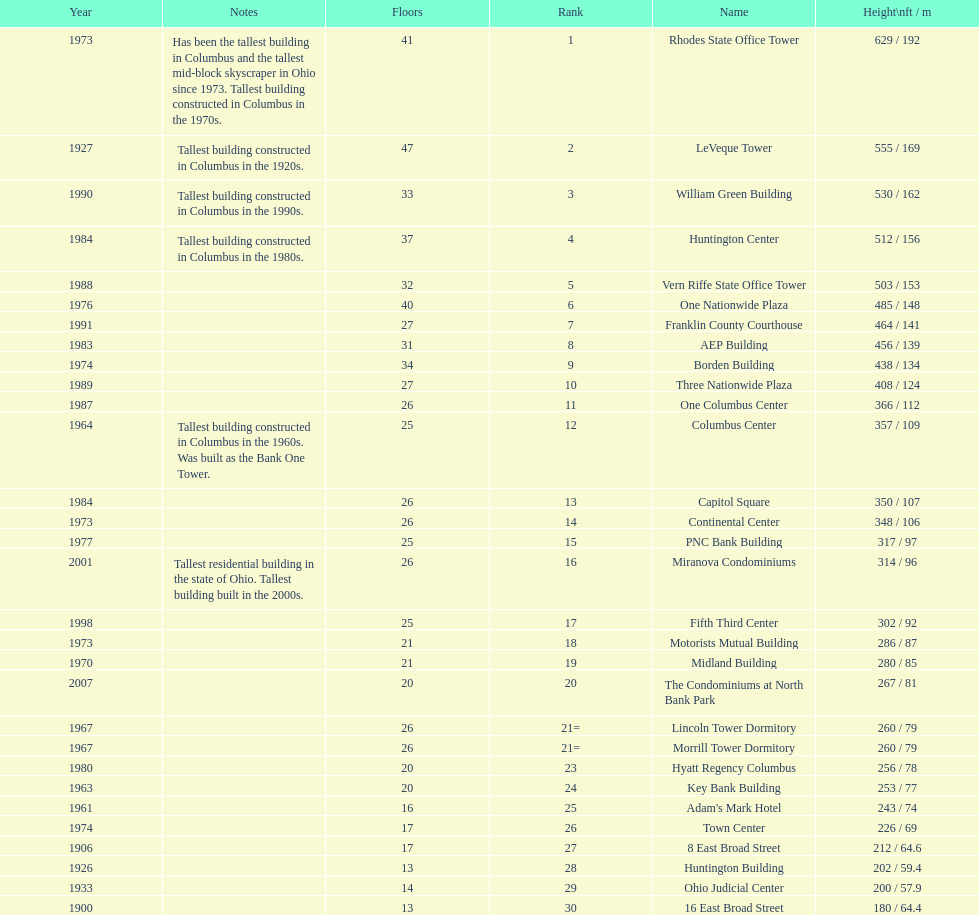What is the tallest building in columbus? Rhodes State Office Tower. 